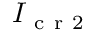<formula> <loc_0><loc_0><loc_500><loc_500>I _ { c r 2 }</formula> 